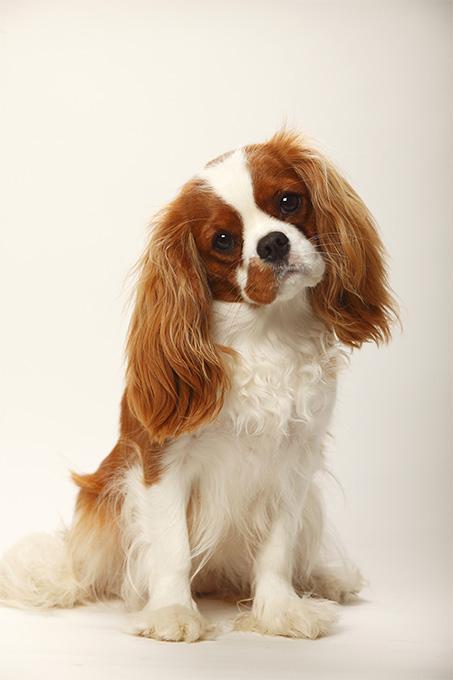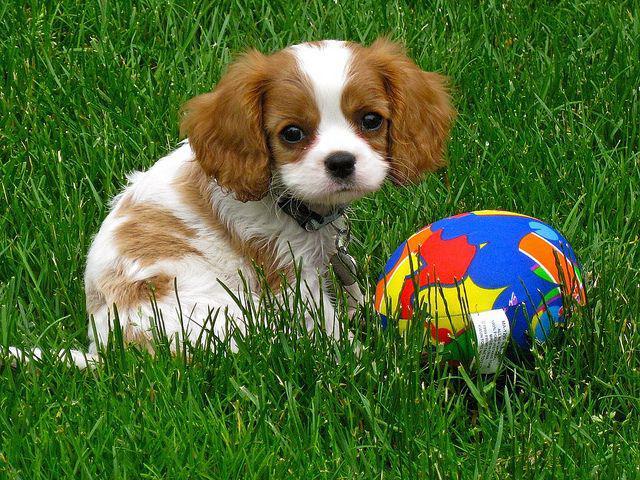The first image is the image on the left, the second image is the image on the right. For the images shown, is this caption "There are at most 2 puppies." true? Answer yes or no. Yes. The first image is the image on the left, the second image is the image on the right. Considering the images on both sides, is "There are no more than two puppies." valid? Answer yes or no. Yes. 